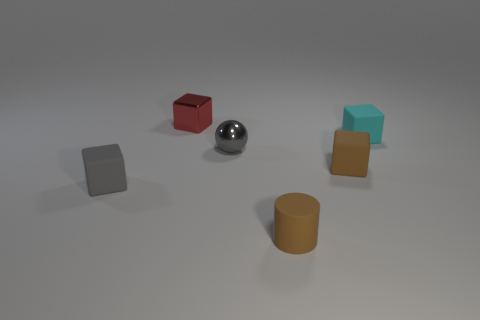Subtract 1 blocks. How many blocks are left? 3 Add 3 red matte balls. How many objects exist? 9 Subtract all blocks. How many objects are left? 2 Subtract all brown cylinders. Subtract all small brown cylinders. How many objects are left? 4 Add 5 matte blocks. How many matte blocks are left? 8 Add 3 cyan things. How many cyan things exist? 4 Subtract 0 blue spheres. How many objects are left? 6 